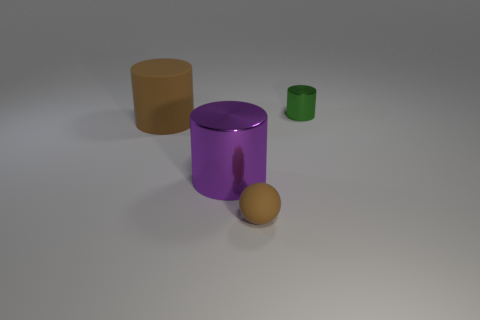Subtract all rubber cylinders. How many cylinders are left? 2 Add 2 tiny blue matte things. How many objects exist? 6 Subtract 0 blue cylinders. How many objects are left? 4 Subtract all cylinders. How many objects are left? 1 Subtract all red cylinders. Subtract all cyan blocks. How many cylinders are left? 3 Subtract all tiny metal things. Subtract all matte cylinders. How many objects are left? 2 Add 4 small green metallic cylinders. How many small green metallic cylinders are left? 5 Add 3 large gray balls. How many large gray balls exist? 3 